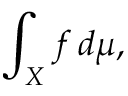<formula> <loc_0><loc_0><loc_500><loc_500>\int _ { X } f \, d \mu ,</formula> 